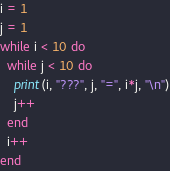<code> <loc_0><loc_0><loc_500><loc_500><_Ruby_>i = 1
j = 1
while i < 10 do
  while j < 10 do
    print(i, "???", j, "=", i*j, "\n")
    j++
  end
  i++
end</code> 